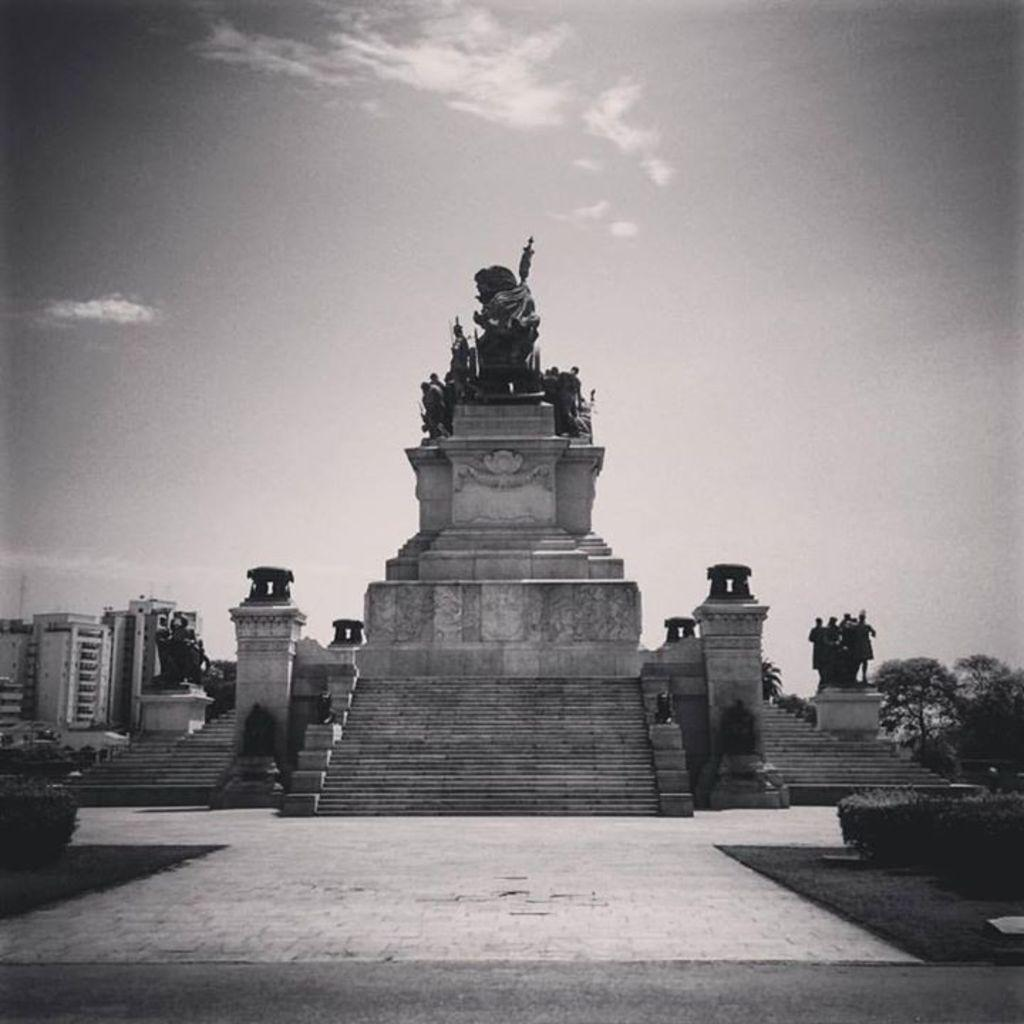What can be seen in the image that resembles human figures? There are statues in the image that resemble human figures. What architectural feature is present in the image? There is a staircase in the image. What structures are located on the left side of the image? There are buildings on the left side of the image. What type of vegetation is on the right side of the image? There are trees on the right side of the image. What can be seen in the sky in the image? There are clouds visible in the sky. Where is the tramp located in the image? There is no tramp present in the image. What type of yarn is being used to create the buildings in the image? The buildings in the image are not made of yarn; they are solid structures. 